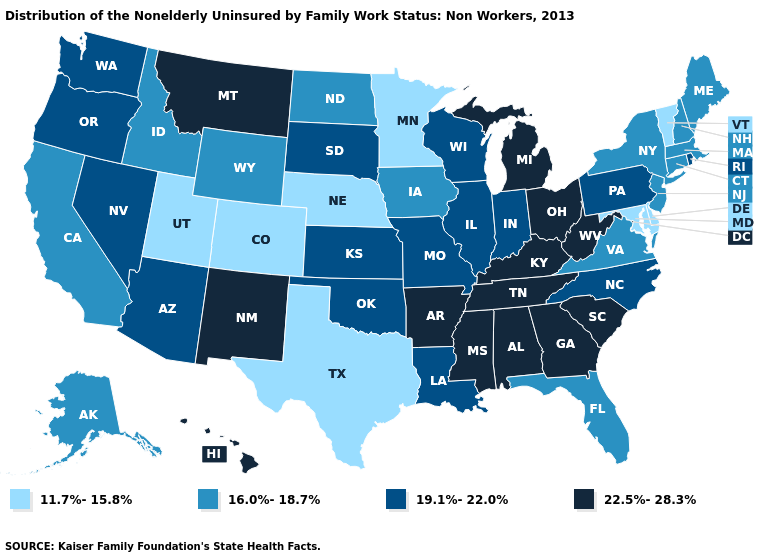Among the states that border Kansas , which have the highest value?
Answer briefly. Missouri, Oklahoma. What is the lowest value in the USA?
Be succinct. 11.7%-15.8%. What is the value of Colorado?
Concise answer only. 11.7%-15.8%. Does Idaho have the lowest value in the West?
Quick response, please. No. Does Florida have the lowest value in the South?
Write a very short answer. No. Among the states that border New York , does Connecticut have the highest value?
Quick response, please. No. Among the states that border Texas , which have the highest value?
Concise answer only. Arkansas, New Mexico. How many symbols are there in the legend?
Concise answer only. 4. Does South Dakota have the highest value in the USA?
Short answer required. No. What is the value of Washington?
Give a very brief answer. 19.1%-22.0%. Does Delaware have the same value as Maryland?
Write a very short answer. Yes. What is the value of Rhode Island?
Concise answer only. 19.1%-22.0%. Name the states that have a value in the range 22.5%-28.3%?
Keep it brief. Alabama, Arkansas, Georgia, Hawaii, Kentucky, Michigan, Mississippi, Montana, New Mexico, Ohio, South Carolina, Tennessee, West Virginia. What is the value of West Virginia?
Short answer required. 22.5%-28.3%. What is the lowest value in the USA?
Keep it brief. 11.7%-15.8%. 